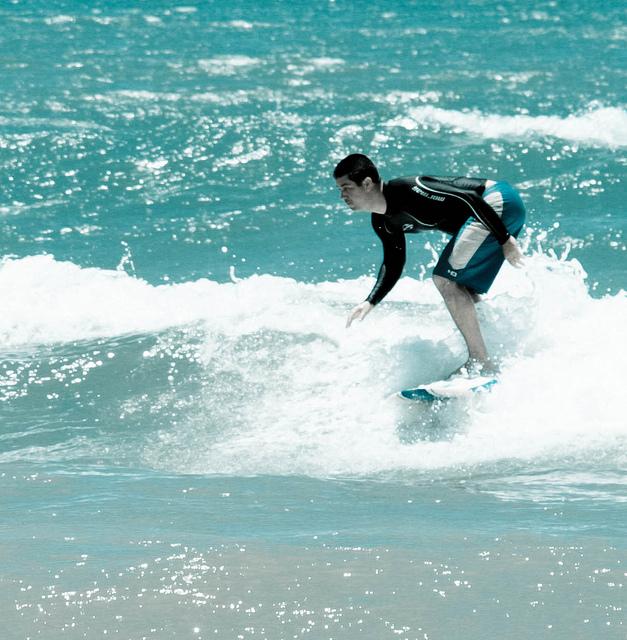Is this a large wave?
Give a very brief answer. No. Is the surfer young?
Short answer required. Yes. What is this person doing?
Give a very brief answer. Surfing. 